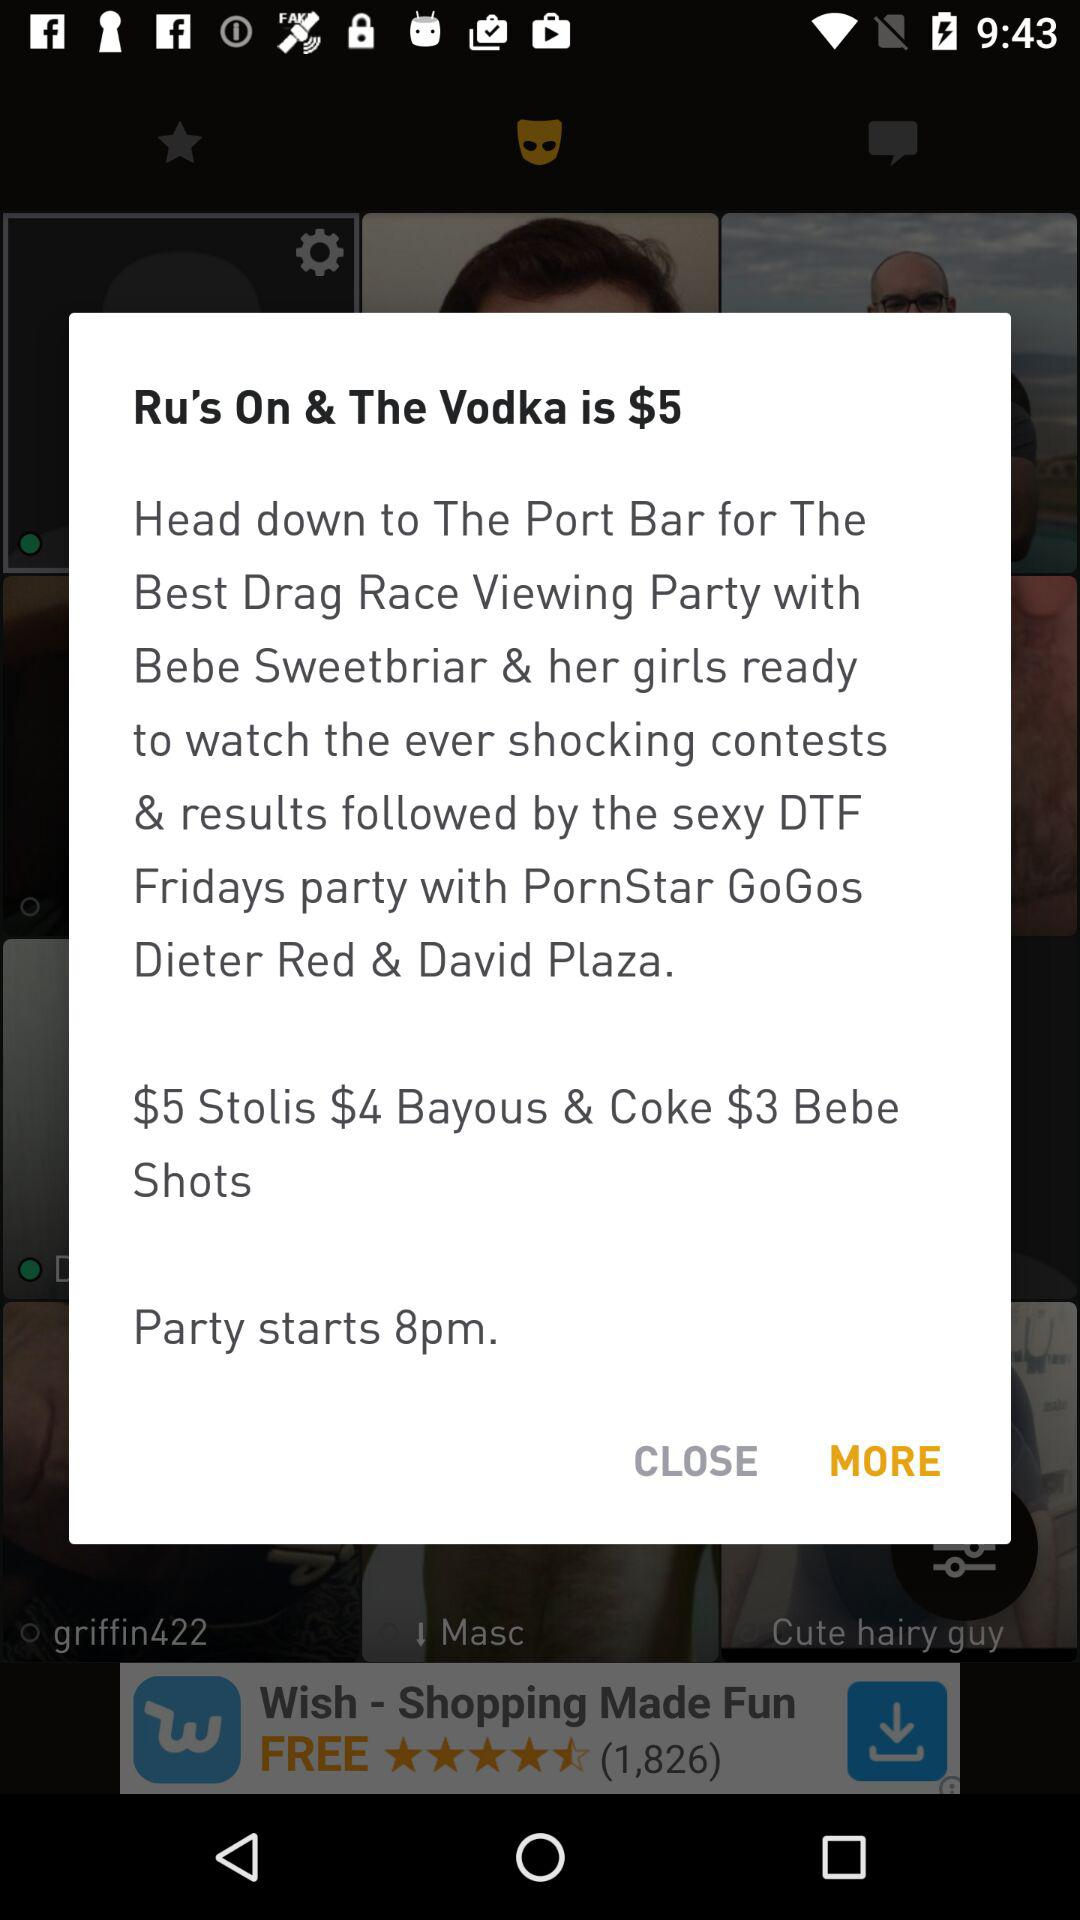What is the price of Stolis? The price of Stolis is $5. 